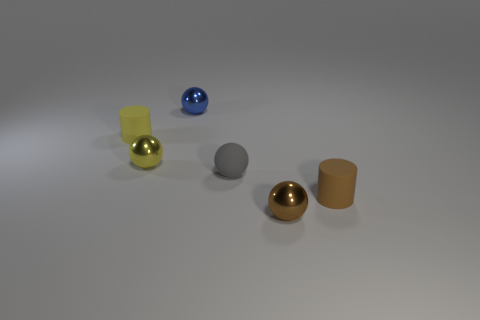There is a matte object that is left of the rubber sphere; does it have the same size as the tiny blue metal sphere?
Offer a terse response. Yes. The blue sphere is what size?
Offer a very short reply. Small. What number of large objects are either gray rubber objects or gray matte blocks?
Provide a short and direct response. 0. How many cylinders are to the left of the gray object?
Your answer should be very brief. 1. The object that is behind the yellow shiny thing and left of the small blue shiny sphere has what shape?
Ensure brevity in your answer.  Cylinder. What number of cubes are either green objects or yellow objects?
Make the answer very short. 0. Is the number of metallic objects that are on the left side of the tiny rubber ball less than the number of small brown matte things?
Ensure brevity in your answer.  No. There is a sphere that is both in front of the yellow rubber object and behind the gray rubber thing; what color is it?
Ensure brevity in your answer.  Yellow. How many other things are the same shape as the yellow metallic thing?
Your answer should be compact. 3. Are there fewer small rubber balls that are left of the small blue shiny ball than tiny matte cylinders on the left side of the small rubber sphere?
Your answer should be very brief. Yes. 